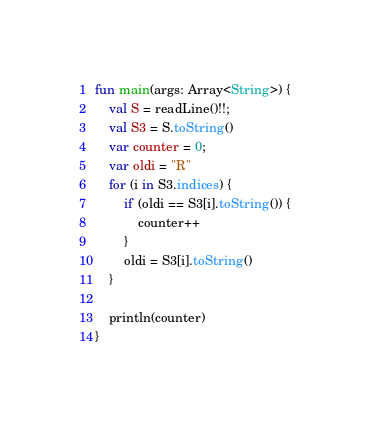Convert code to text. <code><loc_0><loc_0><loc_500><loc_500><_Kotlin_>fun main(args: Array<String>) {
    val S = readLine()!!;
    val S3 = S.toString()
    var counter = 0;
    var oldi = "R"
    for (i in S3.indices) {
        if (oldi == S3[i].toString()) {
            counter++
        }
        oldi = S3[i].toString()
    }

    println(counter)
}</code> 